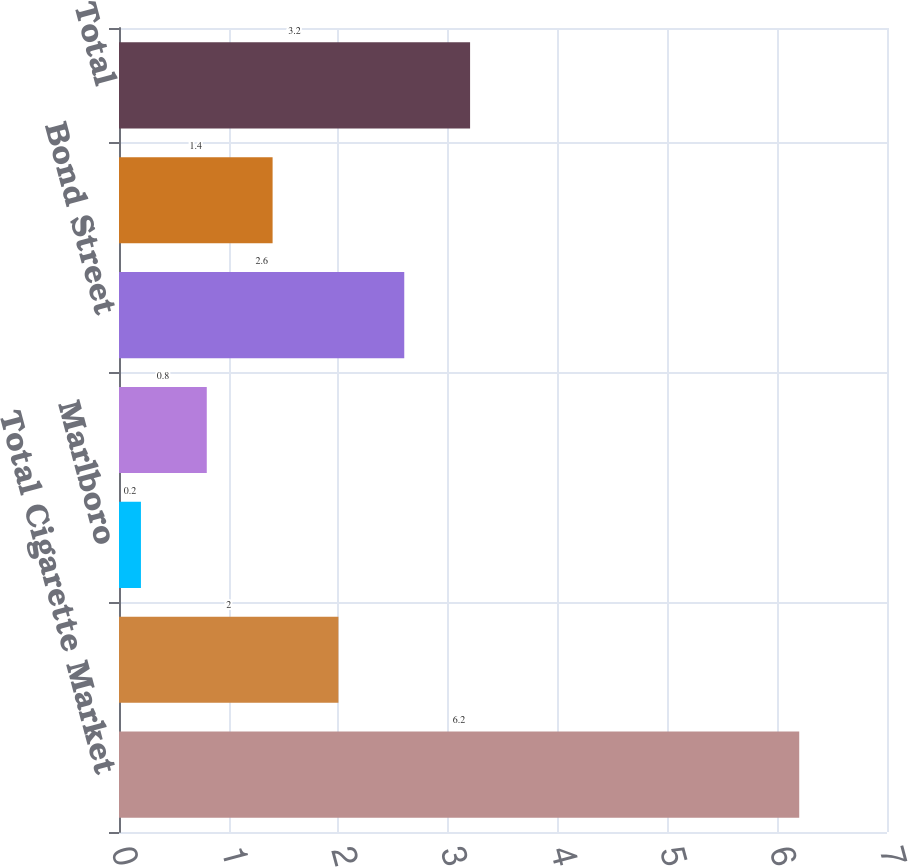<chart> <loc_0><loc_0><loc_500><loc_500><bar_chart><fcel>Total Cigarette Market<fcel>PMI Shipments (million units)<fcel>Marlboro<fcel>Parliament<fcel>Bond Street<fcel>Others<fcel>Total<nl><fcel>6.2<fcel>2<fcel>0.2<fcel>0.8<fcel>2.6<fcel>1.4<fcel>3.2<nl></chart> 